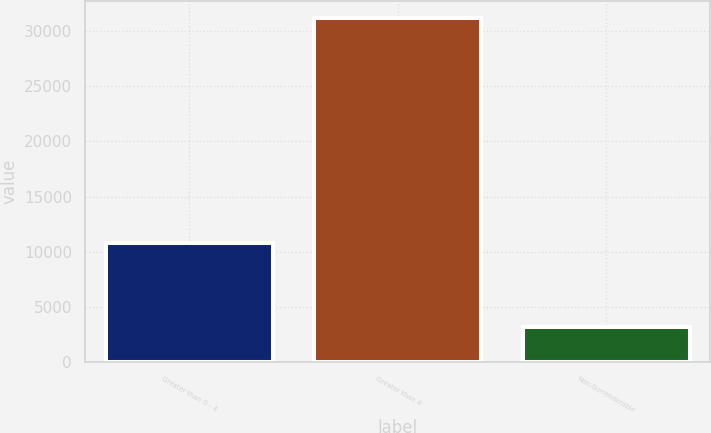Convert chart. <chart><loc_0><loc_0><loc_500><loc_500><bar_chart><fcel>Greater than 0 - 4<fcel>Greater than 4<fcel>Non-Surrenderable<nl><fcel>10815<fcel>31183<fcel>3148<nl></chart> 